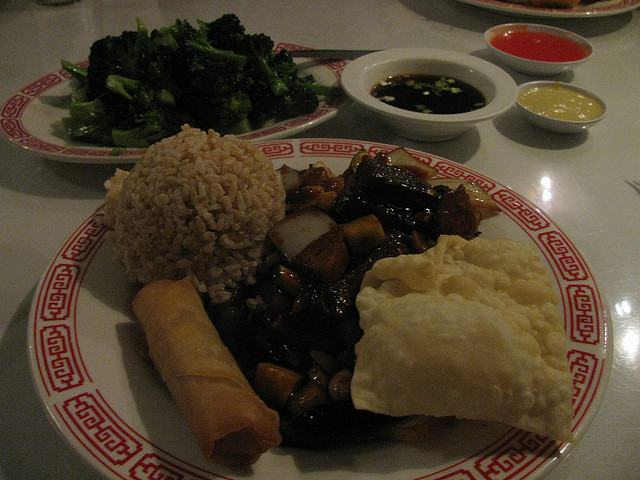<image>What may they be celebrating? It is ambiguous what they may be celebrating. It could be Chinese New Year, a birthday, or a promotion. What kind of fish is on the plate? There is no fish on the plate. However, if there was, it could potentially be cod, bass or catfish. What may they be celebrating? I don't know what they may be celebrating. It can be Chinese New Year, a birthday, a party, or a promotion. What kind of fish is on the plate? There is no fish on the plate. 